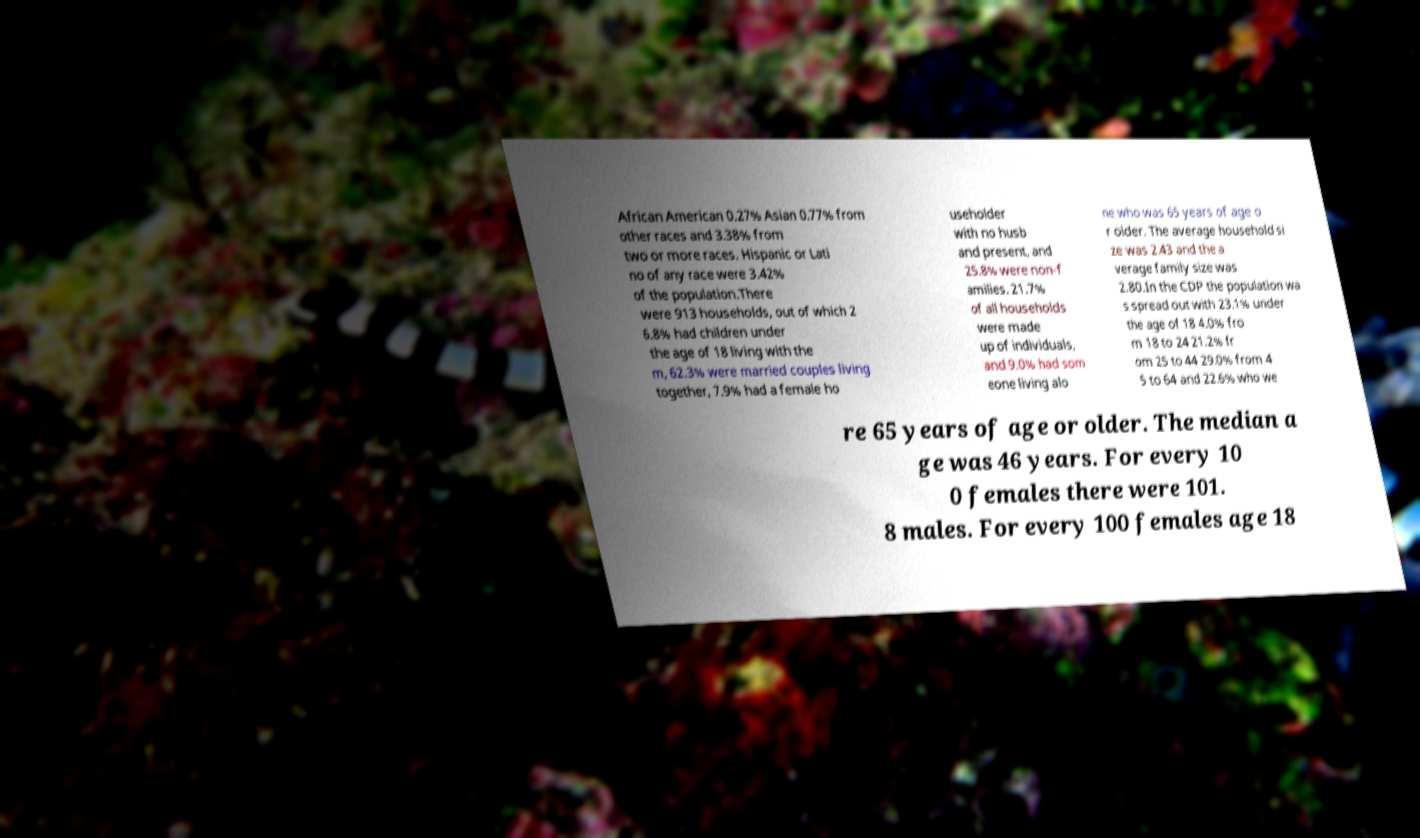I need the written content from this picture converted into text. Can you do that? African American 0.27% Asian 0.77% from other races and 3.38% from two or more races. Hispanic or Lati no of any race were 3.42% of the population.There were 913 households, out of which 2 6.8% had children under the age of 18 living with the m, 62.3% were married couples living together, 7.9% had a female ho useholder with no husb and present, and 25.8% were non-f amilies. 21.7% of all households were made up of individuals, and 9.0% had som eone living alo ne who was 65 years of age o r older. The average household si ze was 2.43 and the a verage family size was 2.80.In the CDP the population wa s spread out with 23.1% under the age of 18 4.0% fro m 18 to 24 21.2% fr om 25 to 44 29.0% from 4 5 to 64 and 22.6% who we re 65 years of age or older. The median a ge was 46 years. For every 10 0 females there were 101. 8 males. For every 100 females age 18 